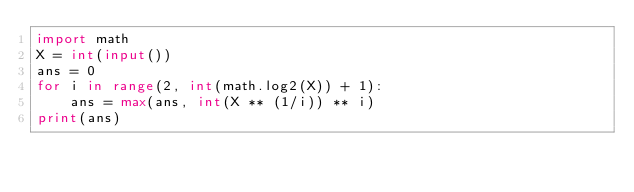Convert code to text. <code><loc_0><loc_0><loc_500><loc_500><_Python_>import math
X = int(input())
ans = 0
for i in range(2, int(math.log2(X)) + 1):
    ans = max(ans, int(X ** (1/i)) ** i)
print(ans)</code> 